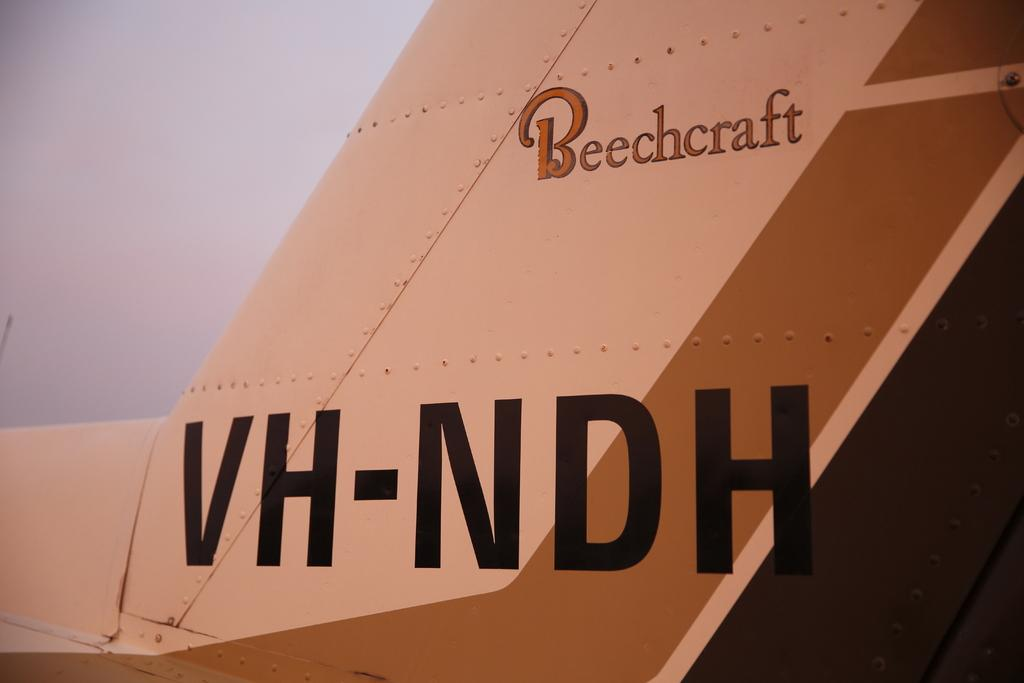Provide a one-sentence caption for the provided image. A wing of a plane in beige and tan with Beechcraft and VH-NDH written on the side. 